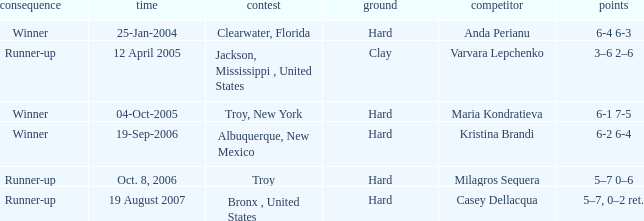What was the surface of the game that resulted in a final score of 6-1 7-5? Hard. 